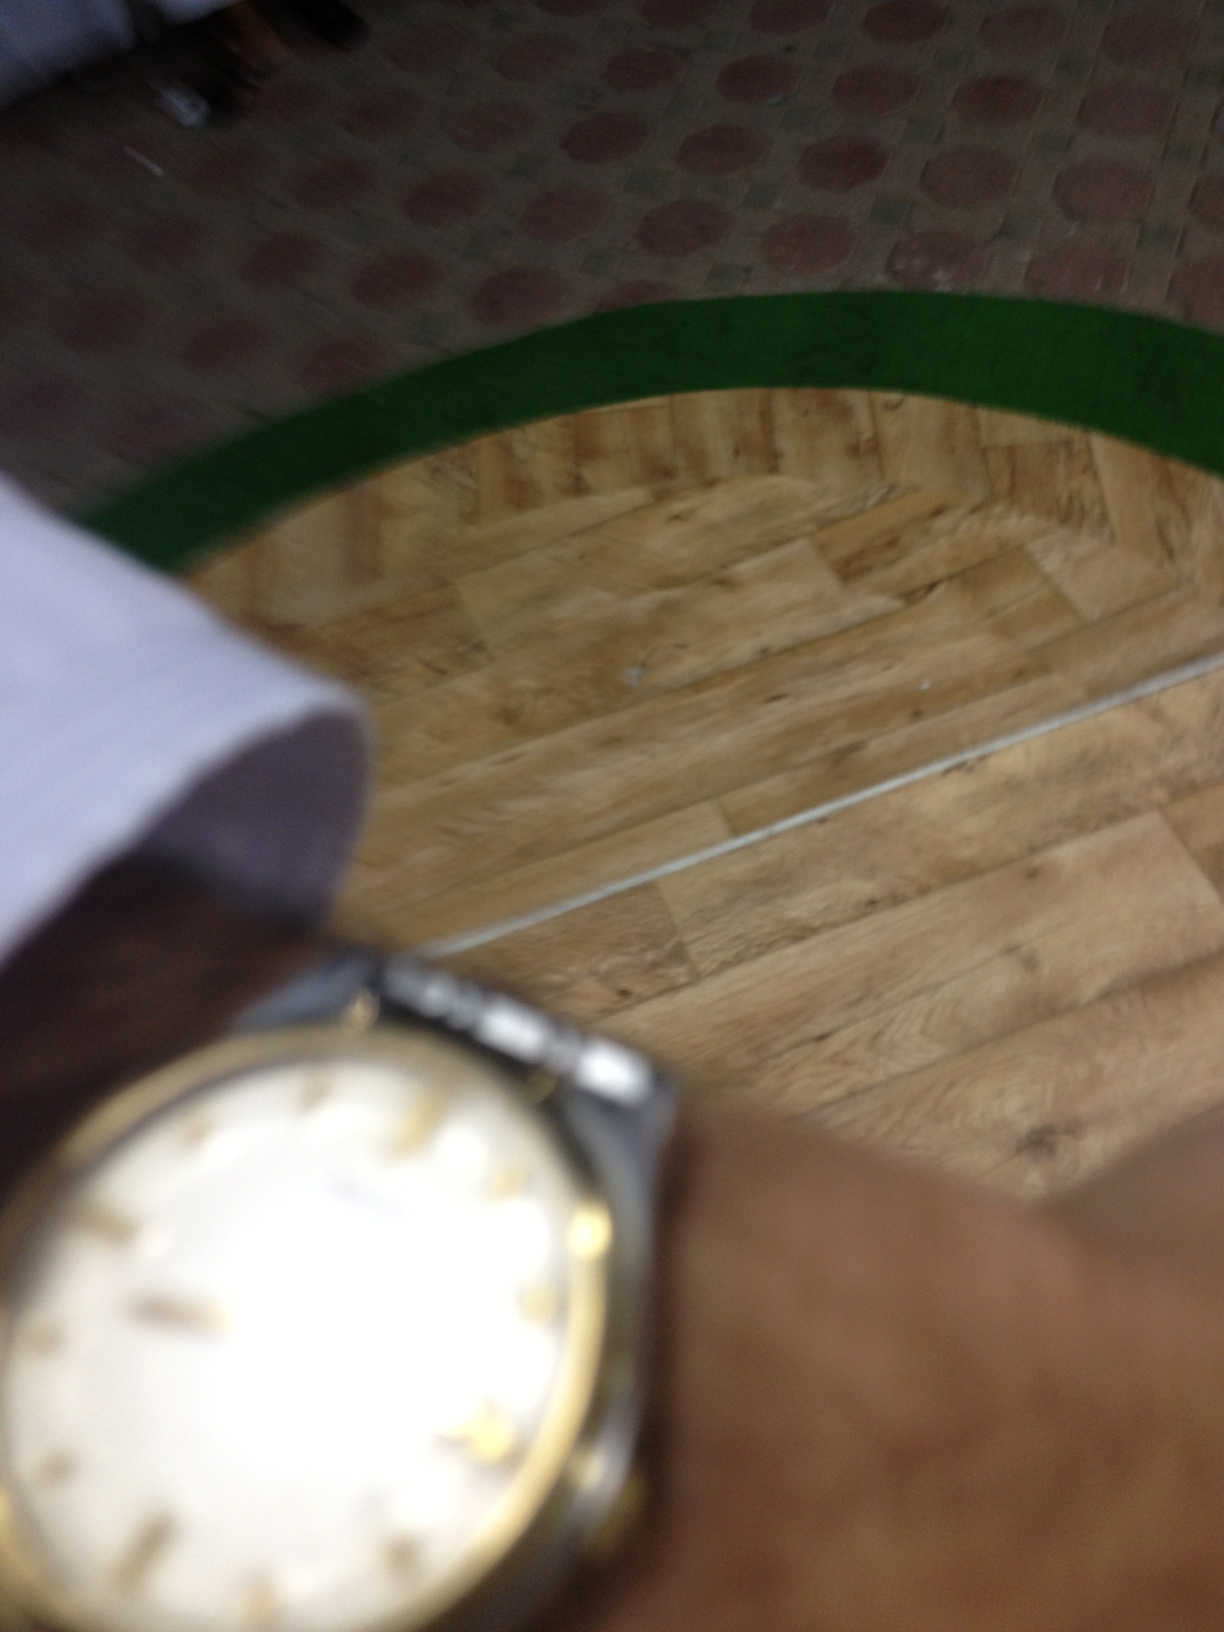what's this? from Vizwiz This image features a wristwatch, likely a men's model given its robust design, with a gold-toned bezel and a leather band. The watch face includes Roman numerals but it appears slightly out of focus, and there's a green stripe partially visible in the blurred background suggesting an indoor setting. 